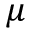Convert formula to latex. <formula><loc_0><loc_0><loc_500><loc_500>\mu</formula> 